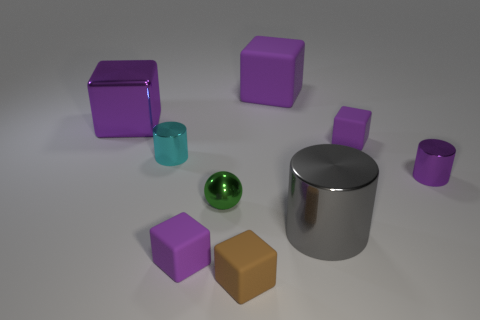Subtract all blue cylinders. How many purple cubes are left? 4 Subtract all purple metal blocks. How many blocks are left? 4 Subtract all brown blocks. How many blocks are left? 4 Subtract all blue blocks. Subtract all green balls. How many blocks are left? 5 Add 1 small brown metal blocks. How many objects exist? 10 Subtract all spheres. How many objects are left? 8 Add 5 purple things. How many purple things exist? 10 Subtract 0 yellow cylinders. How many objects are left? 9 Subtract all big gray shiny things. Subtract all tiny blue shiny blocks. How many objects are left? 8 Add 4 tiny brown matte blocks. How many tiny brown matte blocks are left? 5 